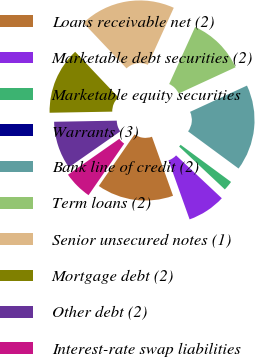<chart> <loc_0><loc_0><loc_500><loc_500><pie_chart><fcel>Loans receivable net (2)<fcel>Marketable debt securities (2)<fcel>Marketable equity securities<fcel>Warrants (3)<fcel>Bank line of credit (2)<fcel>Term loans (2)<fcel>Senior unsecured notes (1)<fcel>Mortgage debt (2)<fcel>Other debt (2)<fcel>Interest-rate swap liabilities<nl><fcel>15.09%<fcel>7.55%<fcel>1.89%<fcel>0.0%<fcel>16.98%<fcel>11.32%<fcel>18.87%<fcel>13.21%<fcel>9.43%<fcel>5.66%<nl></chart> 